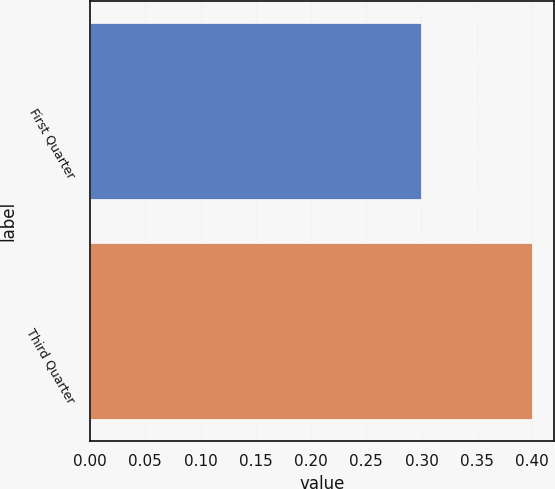Convert chart. <chart><loc_0><loc_0><loc_500><loc_500><bar_chart><fcel>First Quarter<fcel>Third Quarter<nl><fcel>0.3<fcel>0.4<nl></chart> 